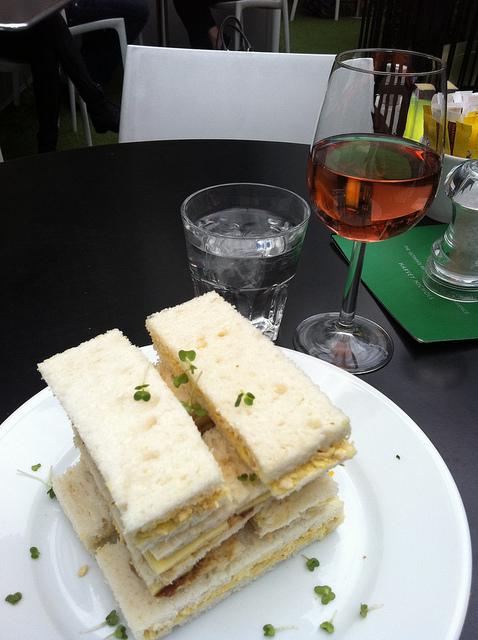Is the pictured wine a pink Zinfandel?
Answer briefly. Yes. Is the drink nearest the camera hot or cold?
Be succinct. Cold. What kind of food is on the plate?
Give a very brief answer. Sandwich. What beverage is likely in the cup?
Quick response, please. Water. Are they having coffee with this cake?
Quick response, please. No. Has the bred been toasted?
Give a very brief answer. No. 